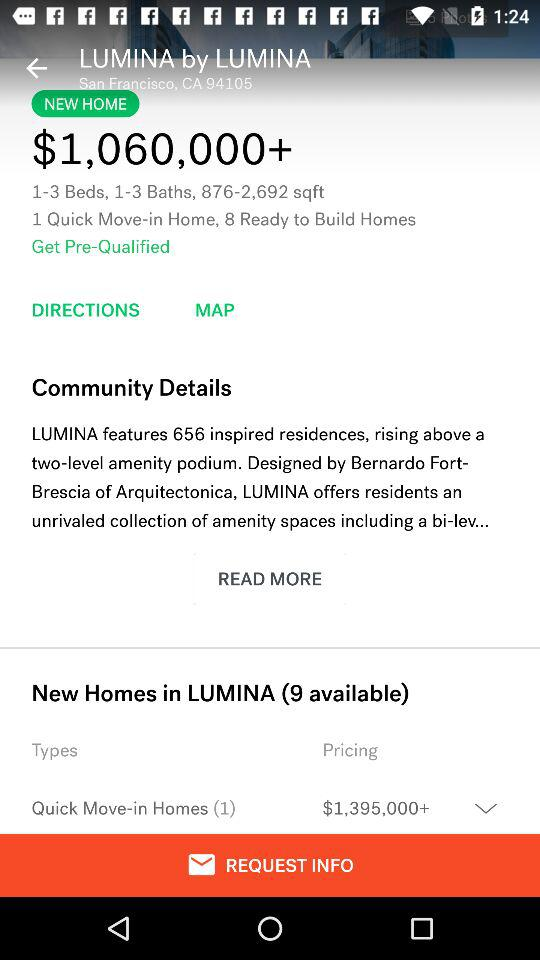What's the area of the house? The area of the house ranges from 876 to 2,692 sq ft. 